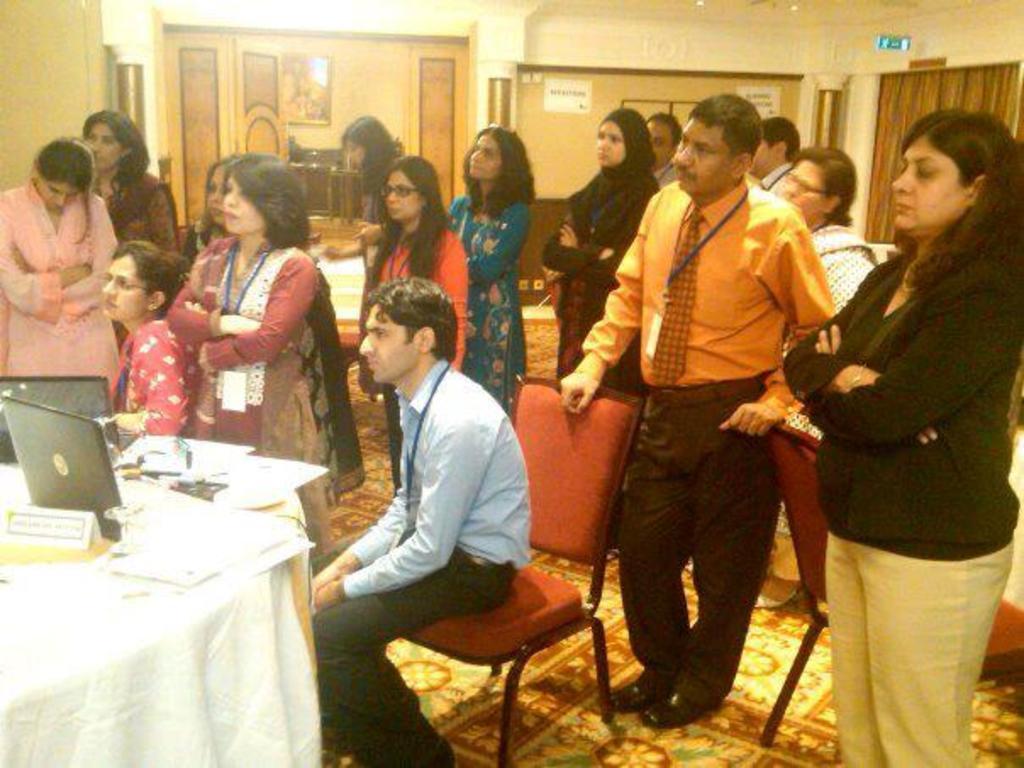Can you describe this image briefly? In this image I see number of people in which most of them are standing and these 2 are sitting, I can also there is a table over here and there are many things on it. In the background I see the wall. 